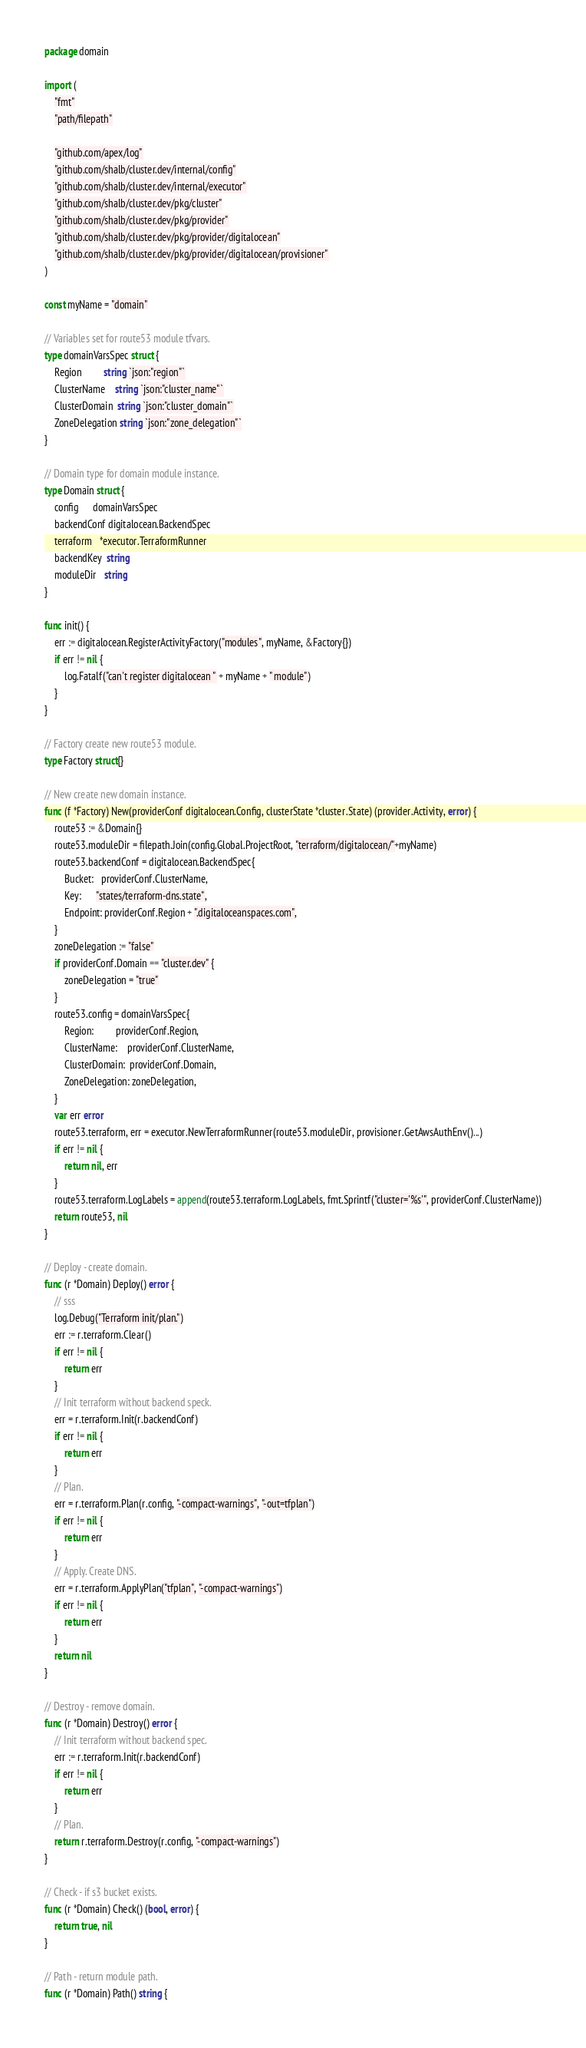Convert code to text. <code><loc_0><loc_0><loc_500><loc_500><_Go_>package domain

import (
	"fmt"
	"path/filepath"

	"github.com/apex/log"
	"github.com/shalb/cluster.dev/internal/config"
	"github.com/shalb/cluster.dev/internal/executor"
	"github.com/shalb/cluster.dev/pkg/cluster"
	"github.com/shalb/cluster.dev/pkg/provider"
	"github.com/shalb/cluster.dev/pkg/provider/digitalocean"
	"github.com/shalb/cluster.dev/pkg/provider/digitalocean/provisioner"
)

const myName = "domain"

// Variables set for route53 module tfvars.
type domainVarsSpec struct {
	Region         string `json:"region"`
	ClusterName    string `json:"cluster_name"`
	ClusterDomain  string `json:"cluster_domain"`
	ZoneDelegation string `json:"zone_delegation"`
}

// Domain type for domain module instance.
type Domain struct {
	config      domainVarsSpec
	backendConf digitalocean.BackendSpec
	terraform   *executor.TerraformRunner
	backendKey  string
	moduleDir   string
}

func init() {
	err := digitalocean.RegisterActivityFactory("modules", myName, &Factory{})
	if err != nil {
		log.Fatalf("can't register digitalocean " + myName + " module")
	}
}

// Factory create new route53 module.
type Factory struct{}

// New create new domain instance.
func (f *Factory) New(providerConf digitalocean.Config, clusterState *cluster.State) (provider.Activity, error) {
	route53 := &Domain{}
	route53.moduleDir = filepath.Join(config.Global.ProjectRoot, "terraform/digitalocean/"+myName)
	route53.backendConf = digitalocean.BackendSpec{
		Bucket:   providerConf.ClusterName,
		Key:      "states/terraform-dns.state",
		Endpoint: providerConf.Region + ".digitaloceanspaces.com",
	}
	zoneDelegation := "false"
	if providerConf.Domain == "cluster.dev" {
		zoneDelegation = "true"
	}
	route53.config = domainVarsSpec{
		Region:         providerConf.Region,
		ClusterName:    providerConf.ClusterName,
		ClusterDomain:  providerConf.Domain,
		ZoneDelegation: zoneDelegation,
	}
	var err error
	route53.terraform, err = executor.NewTerraformRunner(route53.moduleDir, provisioner.GetAwsAuthEnv()...)
	if err != nil {
		return nil, err
	}
	route53.terraform.LogLabels = append(route53.terraform.LogLabels, fmt.Sprintf("cluster='%s'", providerConf.ClusterName))
	return route53, nil
}

// Deploy - create domain.
func (r *Domain) Deploy() error {
	// sss
	log.Debug("Terraform init/plan.")
	err := r.terraform.Clear()
	if err != nil {
		return err
	}
	// Init terraform without backend speck.
	err = r.terraform.Init(r.backendConf)
	if err != nil {
		return err
	}
	// Plan.
	err = r.terraform.Plan(r.config, "-compact-warnings", "-out=tfplan")
	if err != nil {
		return err
	}
	// Apply. Create DNS.
	err = r.terraform.ApplyPlan("tfplan", "-compact-warnings")
	if err != nil {
		return err
	}
	return nil
}

// Destroy - remove domain.
func (r *Domain) Destroy() error {
	// Init terraform without backend spec.
	err := r.terraform.Init(r.backendConf)
	if err != nil {
		return err
	}
	// Plan.
	return r.terraform.Destroy(r.config, "-compact-warnings")
}

// Check - if s3 bucket exists.
func (r *Domain) Check() (bool, error) {
	return true, nil
}

// Path - return module path.
func (r *Domain) Path() string {</code> 